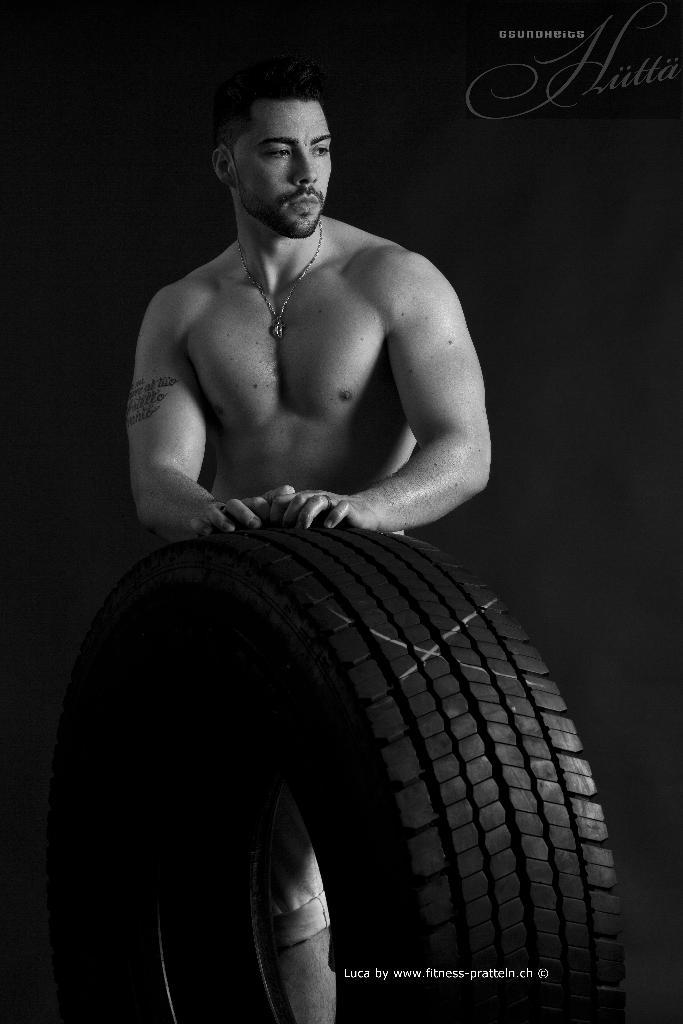Who is the main subject in the image? There is a man in the middle of the image. What object is in front of the man? There is a tire in front of the man. What can be observed about the background of the image? The background of the image is dark. What is the name of the man in the image? The provided facts do not mention the name of the man, so we cannot determine his name from the image. 